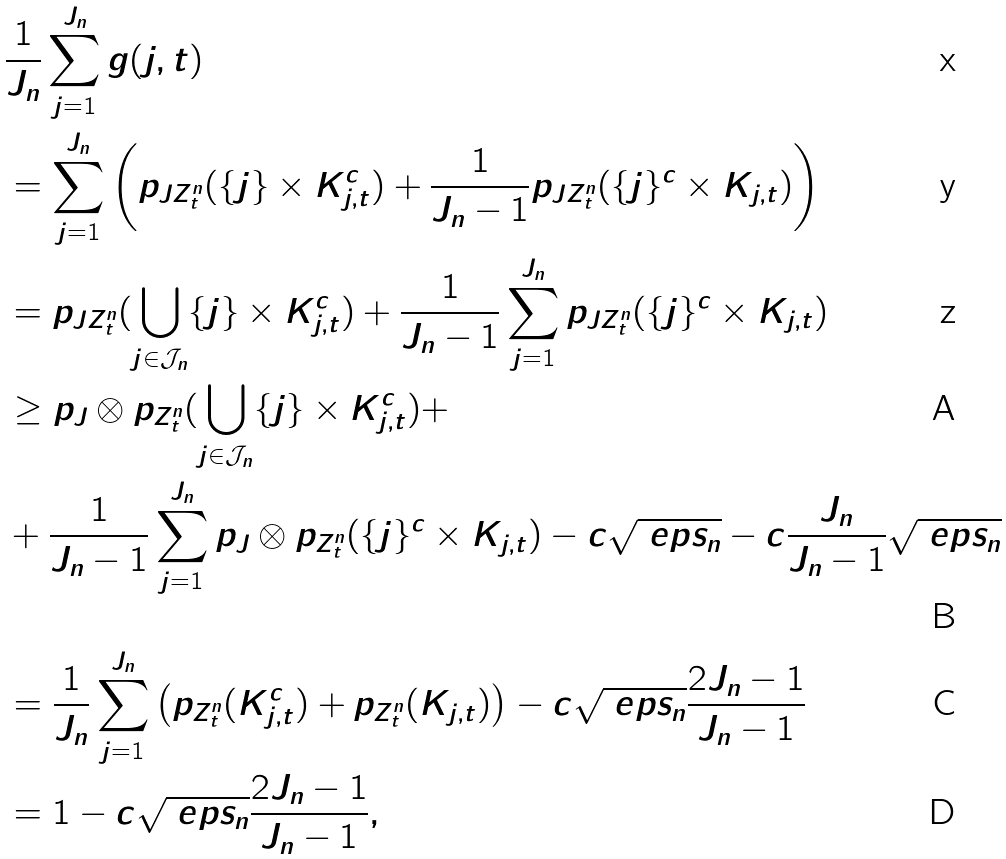<formula> <loc_0><loc_0><loc_500><loc_500>& \frac { 1 } { J _ { n } } \sum _ { j = 1 } ^ { J _ { n } } g ( j , t ) \\ & = \sum _ { j = 1 } ^ { J _ { n } } \left ( p _ { J Z _ { t } ^ { n } } ( \{ j \} \times K _ { j , t } ^ { c } ) + \frac { 1 } { J _ { n } - 1 } p _ { J Z _ { t } ^ { n } } ( \{ j \} ^ { c } \times K _ { j , t } ) \right ) \\ & = p _ { J Z _ { t } ^ { n } } ( \bigcup _ { j \in \mathcal { J } _ { n } } \{ j \} \times K _ { j , t } ^ { c } ) + \frac { 1 } { J _ { n } - 1 } \sum _ { j = 1 } ^ { J _ { n } } p _ { J Z _ { t } ^ { n } } ( \{ j \} ^ { c } \times K _ { j , t } ) \\ & \geq p _ { J } \otimes p _ { Z _ { t } ^ { n } } ( \bigcup _ { j \in \mathcal { J } _ { n } } \{ j \} \times K _ { j , t } ^ { c } ) + \\ & + \frac { 1 } { J _ { n } - 1 } \sum _ { j = 1 } ^ { J _ { n } } p _ { J } \otimes p _ { Z _ { t } ^ { n } } ( \{ j \} ^ { c } \times K _ { j , t } ) - c \sqrt { \ e p s _ { n } } - c \frac { J _ { n } } { J _ { n } - 1 } \sqrt { \ e p s _ { n } } \\ & = \frac { 1 } { J _ { n } } \sum _ { j = 1 } ^ { J _ { n } } \left ( p _ { Z _ { t } ^ { n } } ( K _ { j , t } ^ { c } ) + p _ { Z _ { t } ^ { n } } ( K _ { j , t } ) \right ) - c \sqrt { \ e p s _ { n } } \frac { 2 J _ { n } - 1 } { J _ { n } - 1 } \\ & = 1 - c \sqrt { \ e p s _ { n } } \frac { 2 J _ { n } - 1 } { J _ { n } - 1 } ,</formula> 